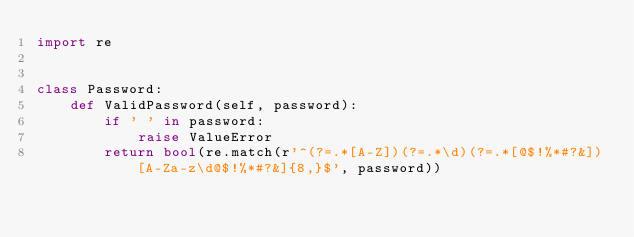Convert code to text. <code><loc_0><loc_0><loc_500><loc_500><_Python_>import re


class Password:
    def ValidPassword(self, password):
        if ' ' in password:
            raise ValueError
        return bool(re.match(r'^(?=.*[A-Z])(?=.*\d)(?=.*[@$!%*#?&])[A-Za-z\d@$!%*#?&]{8,}$', password))
</code> 